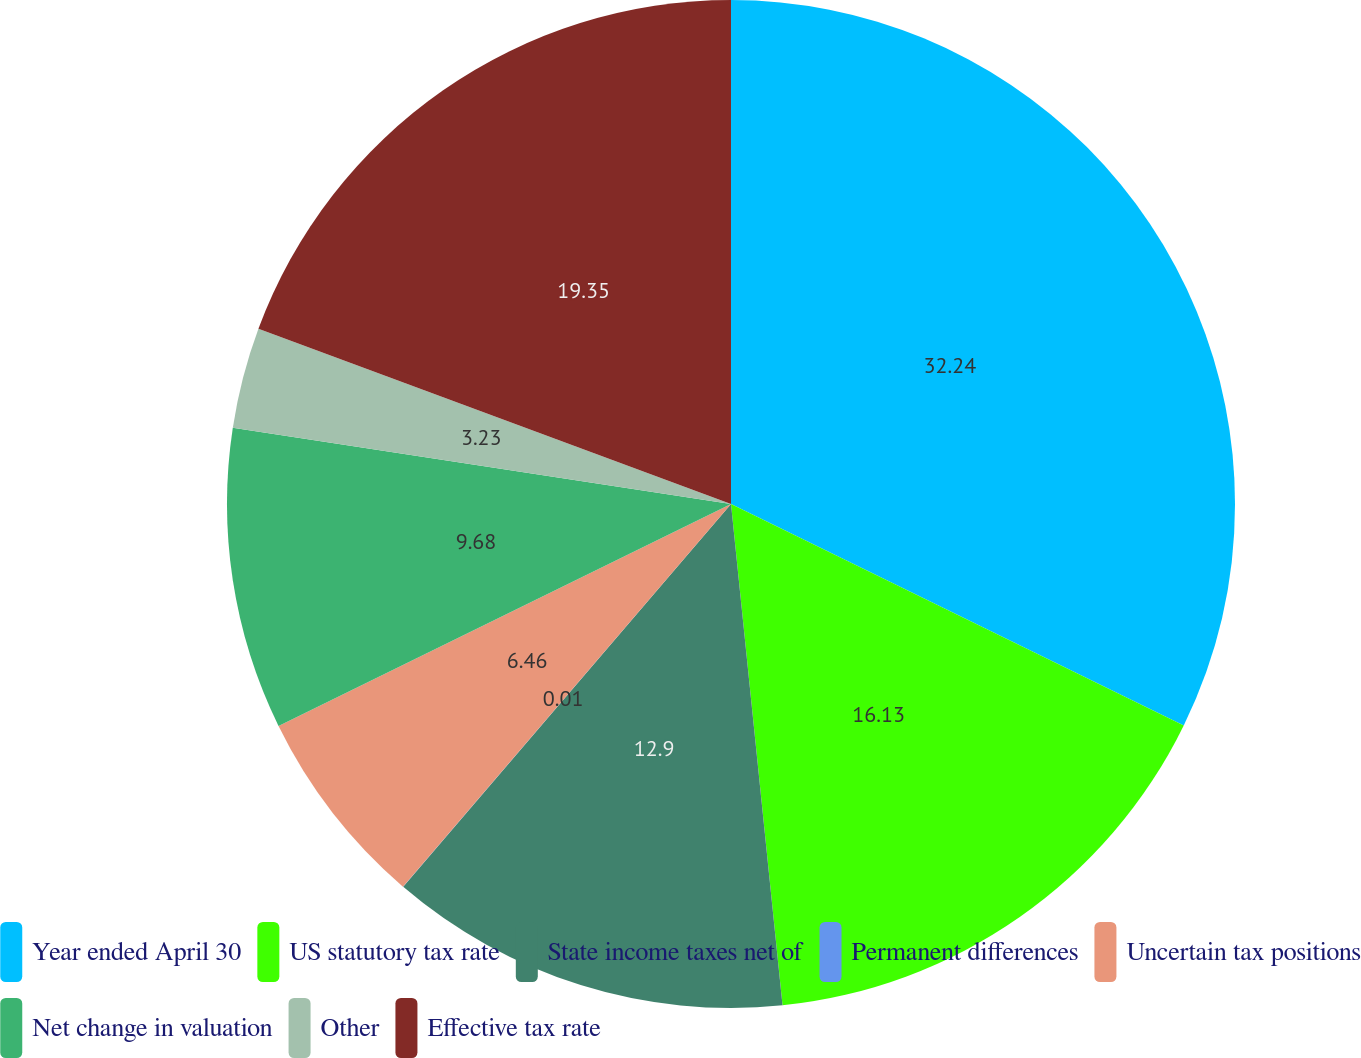<chart> <loc_0><loc_0><loc_500><loc_500><pie_chart><fcel>Year ended April 30<fcel>US statutory tax rate<fcel>State income taxes net of<fcel>Permanent differences<fcel>Uncertain tax positions<fcel>Net change in valuation<fcel>Other<fcel>Effective tax rate<nl><fcel>32.24%<fcel>16.13%<fcel>12.9%<fcel>0.01%<fcel>6.46%<fcel>9.68%<fcel>3.23%<fcel>19.35%<nl></chart> 